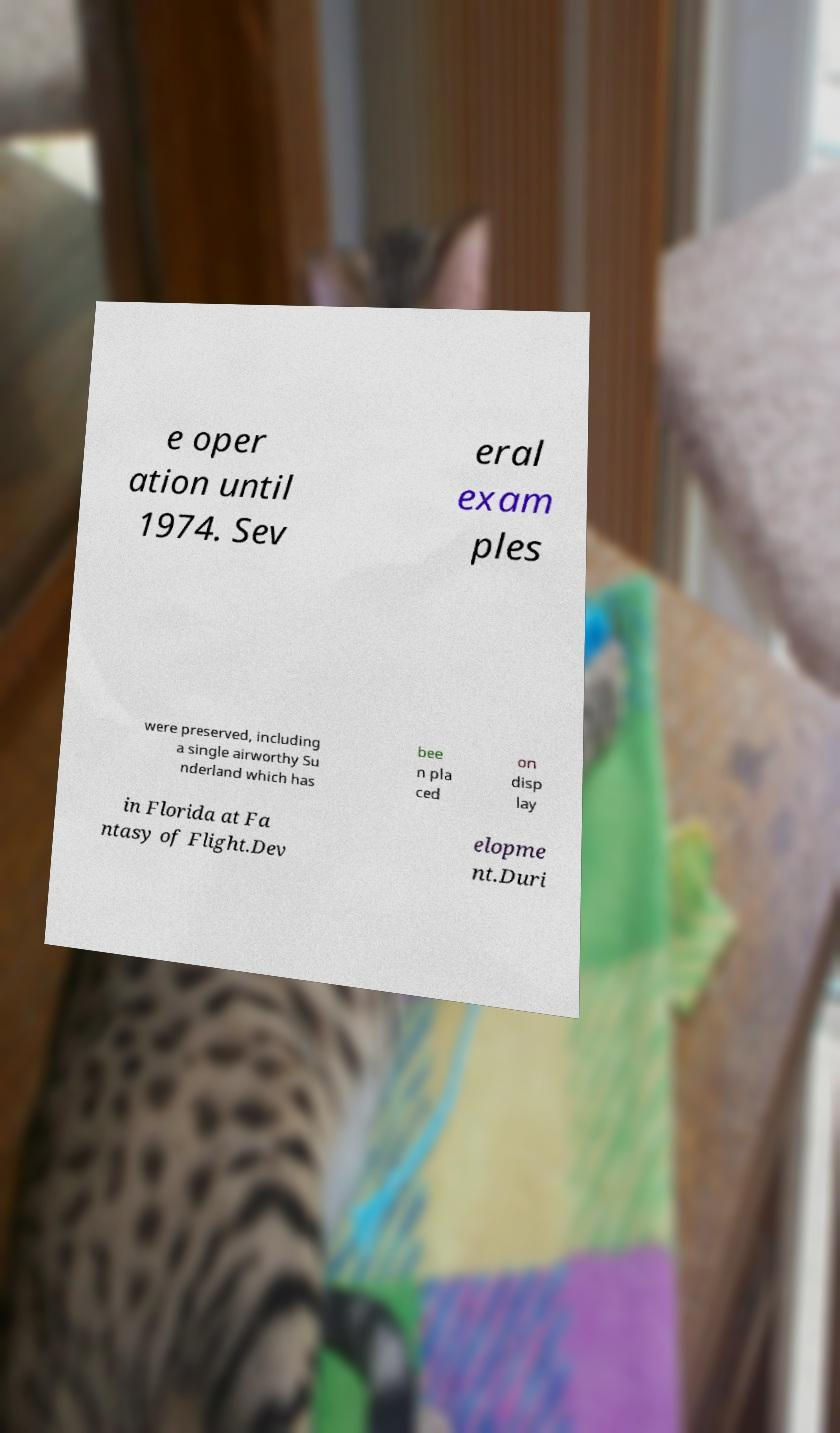What messages or text are displayed in this image? I need them in a readable, typed format. e oper ation until 1974. Sev eral exam ples were preserved, including a single airworthy Su nderland which has bee n pla ced on disp lay in Florida at Fa ntasy of Flight.Dev elopme nt.Duri 